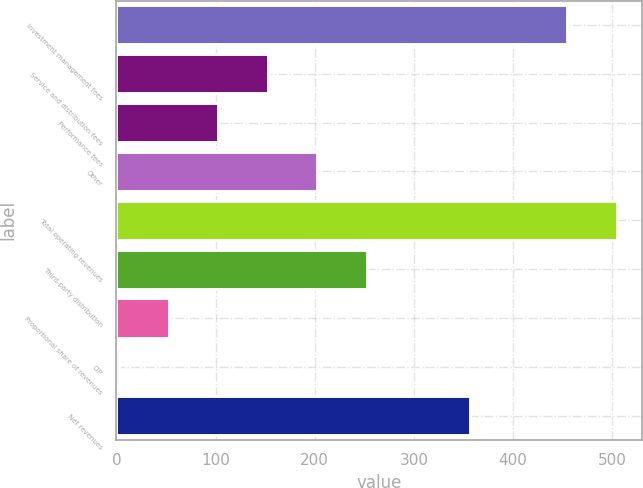Convert chart. <chart><loc_0><loc_0><loc_500><loc_500><bar_chart><fcel>Investment management fees<fcel>Service and distribution fees<fcel>Performance fees<fcel>Other<fcel>Total operating revenues<fcel>Third-party distribution<fcel>Proportional share of revenues<fcel>CIP<fcel>Net revenues<nl><fcel>454.5<fcel>152.64<fcel>102.66<fcel>202.62<fcel>504.48<fcel>252.6<fcel>52.68<fcel>2.7<fcel>356.3<nl></chart> 